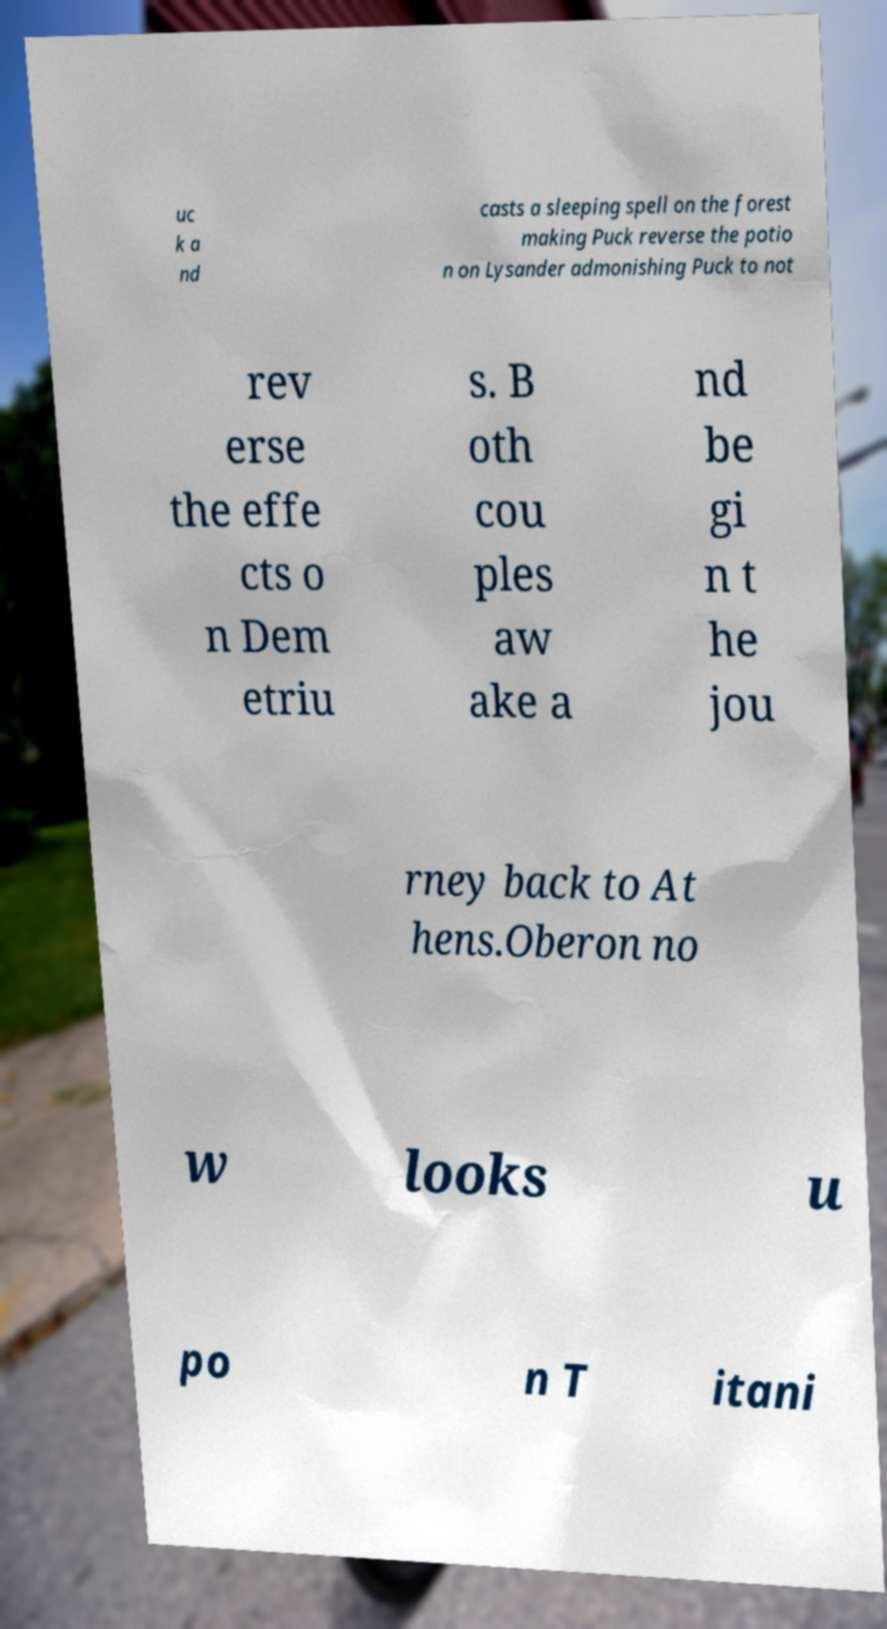Please read and relay the text visible in this image. What does it say? uc k a nd casts a sleeping spell on the forest making Puck reverse the potio n on Lysander admonishing Puck to not rev erse the effe cts o n Dem etriu s. B oth cou ples aw ake a nd be gi n t he jou rney back to At hens.Oberon no w looks u po n T itani 